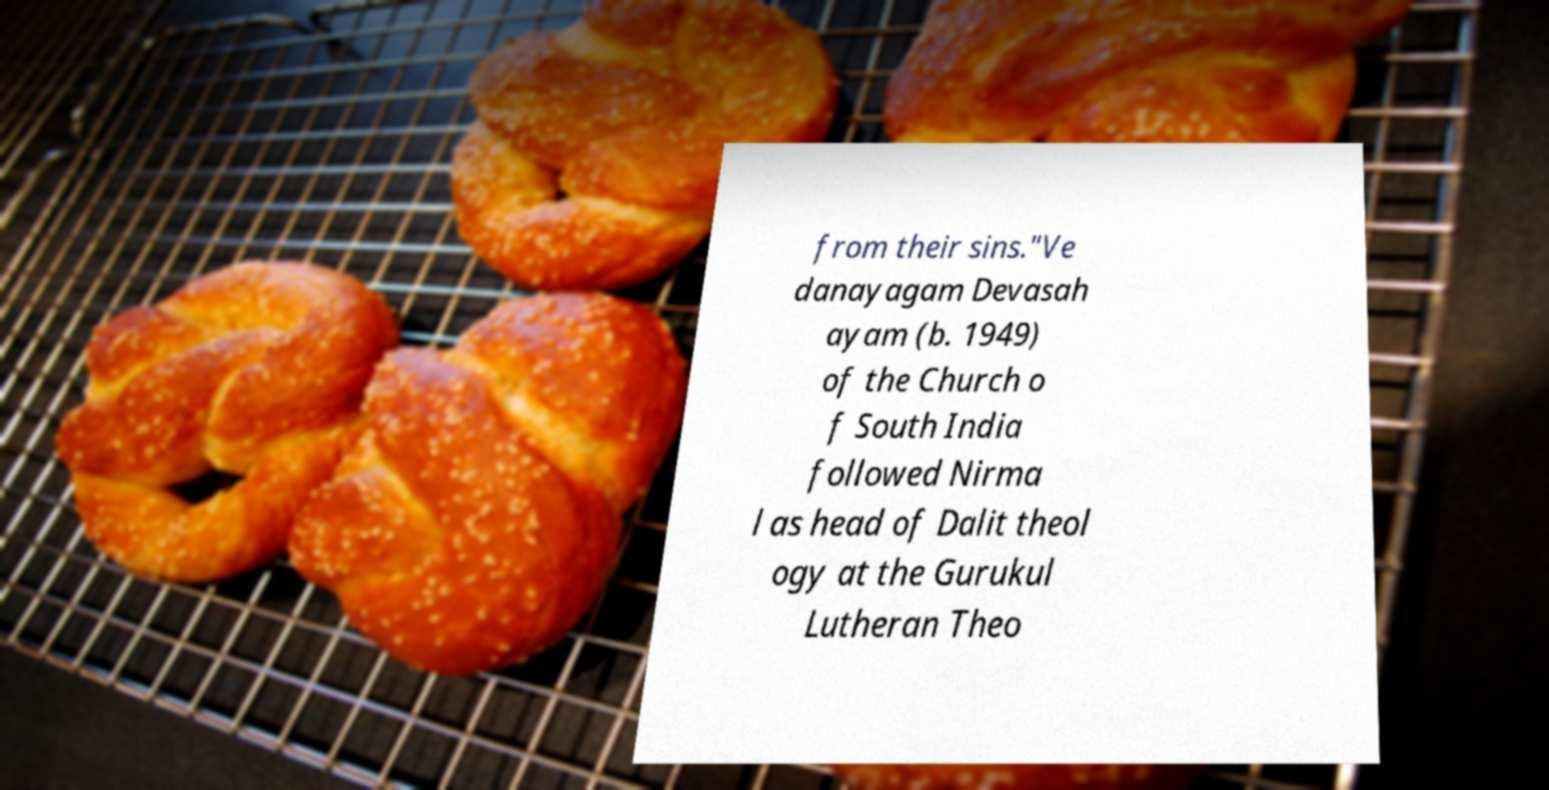I need the written content from this picture converted into text. Can you do that? from their sins."Ve danayagam Devasah ayam (b. 1949) of the Church o f South India followed Nirma l as head of Dalit theol ogy at the Gurukul Lutheran Theo 